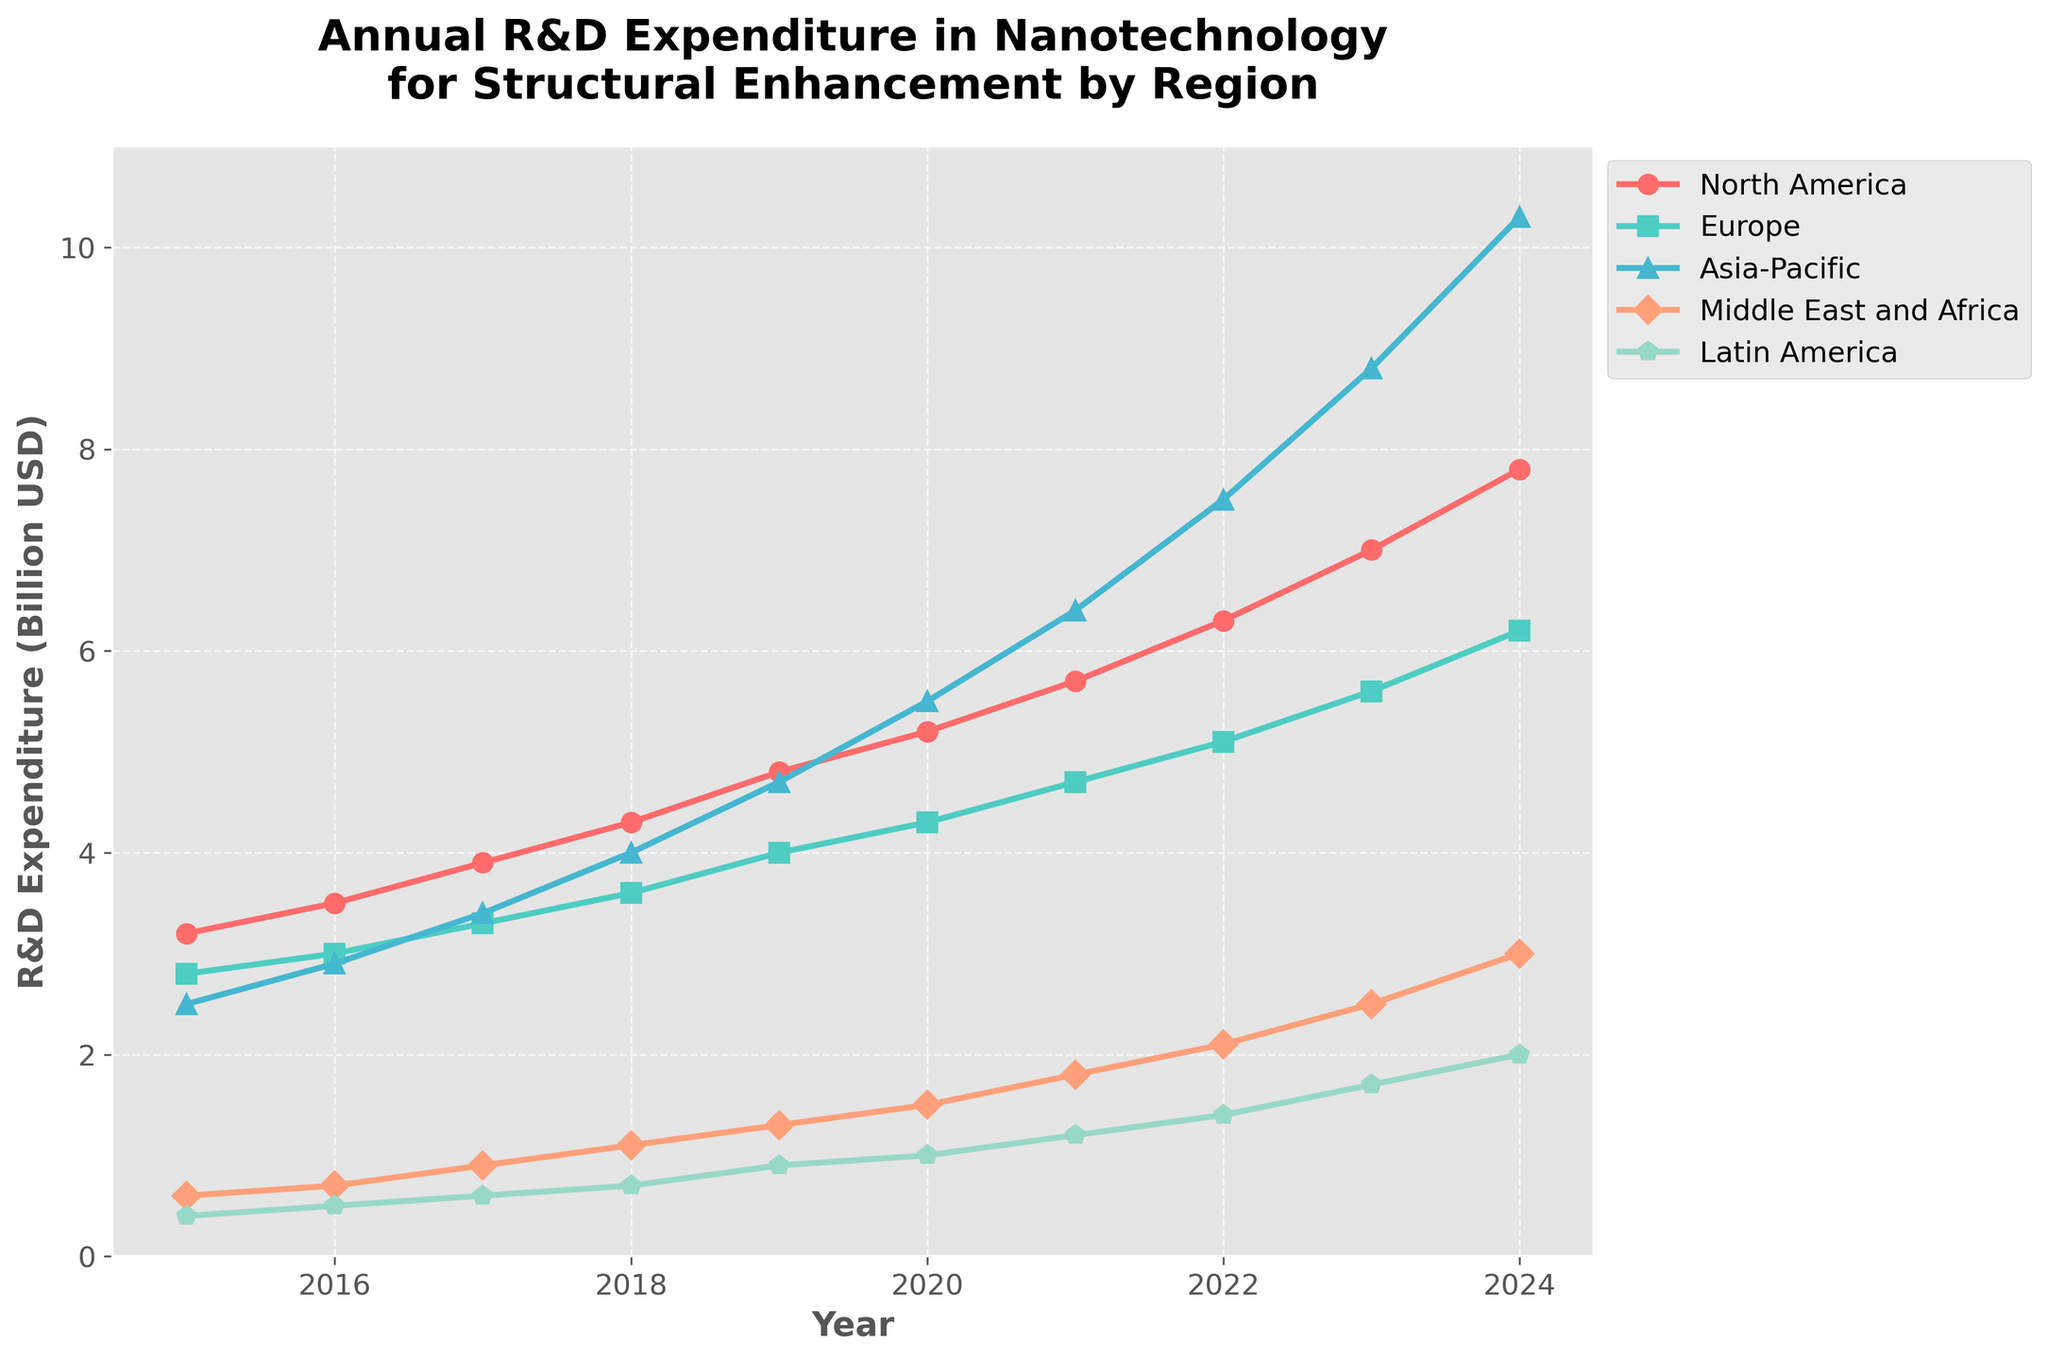Which region had the highest R&D expenditure in 2019? In 2019, look at all the data points for each region and identify the highest one. The data points are North America (4.8), Europe (4.0), Asia-Pacific (4.7), Middle East and Africa (1.3), and Latin America (0.9). The highest expenditure is in North America with 4.8 billion USD.
Answer: North America What is the total R&D expenditure for Europe from 2017 to 2020? Sum the values for Europe from 2017 to 2020: 3.3 (2017) + 3.6 (2018) + 4.0 (2019) + 4.3 (2020) = 15.2 billion USD.
Answer: 15.2 Which region showed the most significant increase in expenditure from 2015 to 2024? Calculate the difference in expenditure for each region from 2015 to 2024: 
North America: 7.8 - 3.2 = 4.6 
Europe: 6.2 - 2.8 = 3.4 
Asia-Pacific: 10.3 - 2.5 = 7.8 
Middle East and Africa: 3.0 - 0.6 = 2.4 
Latin America: 2.0 - 0.4 = 1.6 
Asia-Pacific shows the most significant increase with 7.8 billion USD.
Answer: Asia-Pacific What is the average annual R&D expenditure for Latin America from 2015 to 2024? Sum all values for Latin America from 2015 to 2024 and then divide by the number of years. The values are: 0.4, 0.5, 0.6, 0.7, 0.9, 1.0, 1.2, 1.4, 1.7, 2.0. The sum is 10.4. Divide by 10 years: 10.4/10 = 1.04 billion USD.
Answer: 1.04 From which year did Asia-Pacific's R&D expenditure surpass that of Europe? Check the values for Asia-Pacific and Europe year by year to find the first year when Asia-Pacific's expenditure is greater than Europe's. This happens in 2018: Asia-Pacific (4.0) > Europe (3.6).
Answer: 2018 How much did the Middle East and Africa’s expenditure grow in 2023 compared to 2022? Subtract the 2022 value for Middle East and Africa from the 2023 value: 2.5 (2023) - 2.1 (2022) = 0.4 billion USD.
Answer: 0.4 Which region had the least expenditure in 2024? Compare the data points for each region in 2024, and identify the smallest value: North America (7.8), Europe (6.2), Asia-Pacific (10.3), Middle East and Africa (3.0), Latin America (2.0). Latin America has the least with 2.0 billion USD.
Answer: Latin America What is the difference in R&D expenditure between North America and Europe in 2021? Subtract the 2021 value for Europe from the 2021 value for North America: 5.7 (North America) - 4.7 (Europe) = 1.0 billion USD.
Answer: 1.0 Which region's R&D expenditure showed the smallest growth rate from 2015 to 2020? Calculate the growth rate for each region from 2015 to 2020 using the formula (2020 value - 2015 value) / 2015 value. 
North America: (5.2 - 3.2) / 3.2 = 0.625 
Europe: (4.3 - 2.8) / 2.8 = 0.536 
Asia-Pacific: (5.5 - 2.5) / 2.5 = 1.2 
Middle East and Africa: (1.5 - 0.6) / 0.6 = 1.5 
Latin America: (1.0 - 0.4) / 0.4 = 1.5 
Europe shows the smallest growth rate with 0.536.
Answer: Europe 